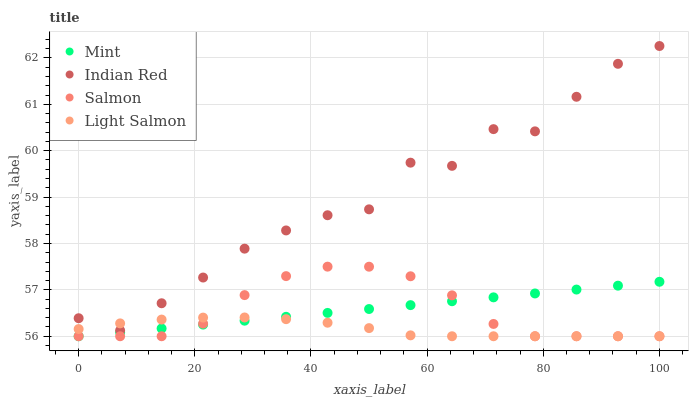Does Light Salmon have the minimum area under the curve?
Answer yes or no. Yes. Does Indian Red have the maximum area under the curve?
Answer yes or no. Yes. Does Mint have the minimum area under the curve?
Answer yes or no. No. Does Mint have the maximum area under the curve?
Answer yes or no. No. Is Mint the smoothest?
Answer yes or no. Yes. Is Indian Red the roughest?
Answer yes or no. Yes. Is Light Salmon the smoothest?
Answer yes or no. No. Is Light Salmon the roughest?
Answer yes or no. No. Does Salmon have the lowest value?
Answer yes or no. Yes. Does Indian Red have the lowest value?
Answer yes or no. No. Does Indian Red have the highest value?
Answer yes or no. Yes. Does Mint have the highest value?
Answer yes or no. No. Is Salmon less than Indian Red?
Answer yes or no. Yes. Is Indian Red greater than Salmon?
Answer yes or no. Yes. Does Light Salmon intersect Mint?
Answer yes or no. Yes. Is Light Salmon less than Mint?
Answer yes or no. No. Is Light Salmon greater than Mint?
Answer yes or no. No. Does Salmon intersect Indian Red?
Answer yes or no. No. 